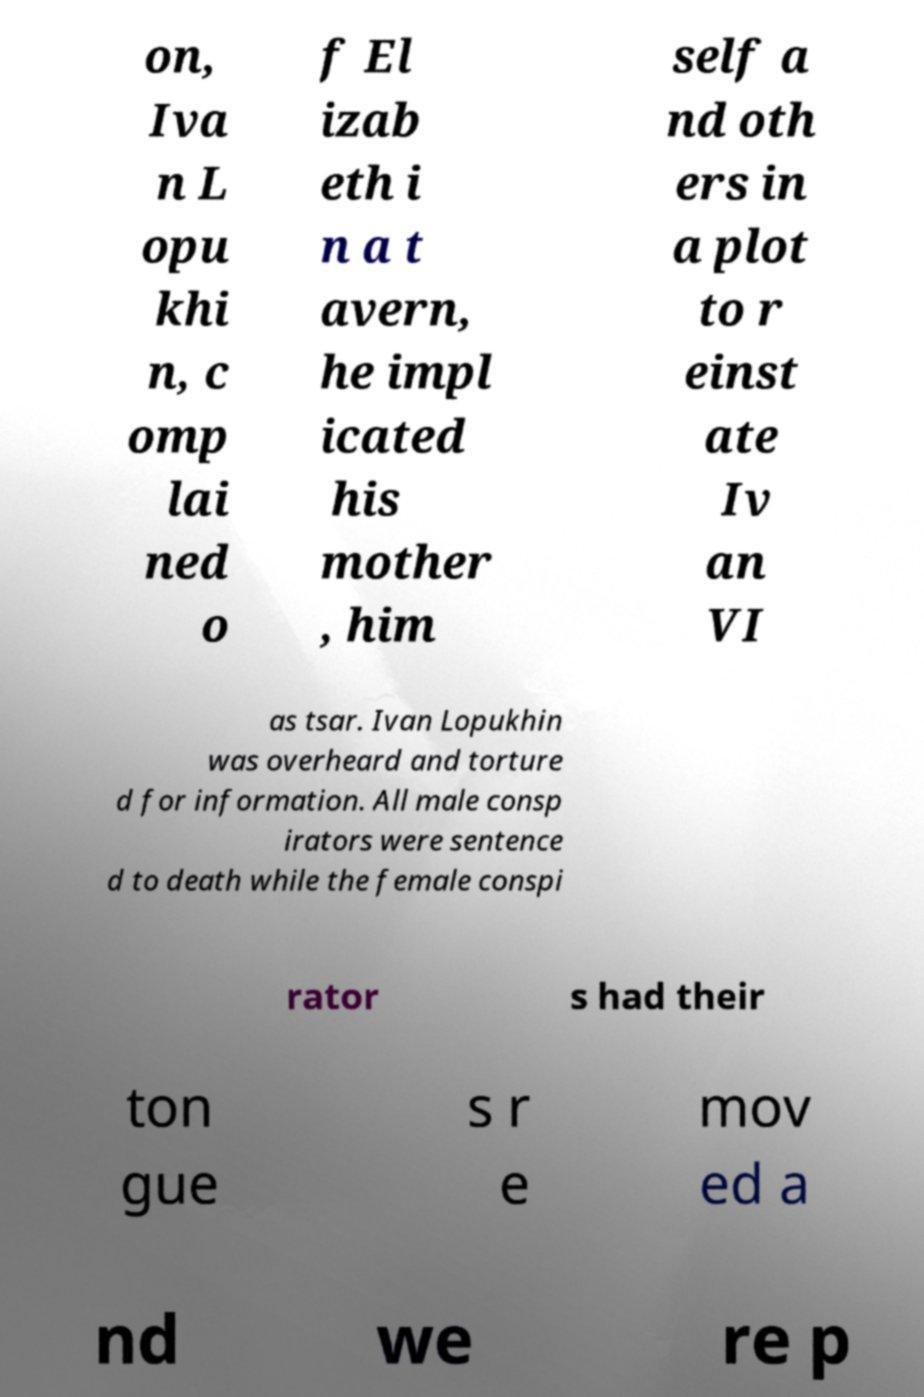What messages or text are displayed in this image? I need them in a readable, typed format. on, Iva n L opu khi n, c omp lai ned o f El izab eth i n a t avern, he impl icated his mother , him self a nd oth ers in a plot to r einst ate Iv an VI as tsar. Ivan Lopukhin was overheard and torture d for information. All male consp irators were sentence d to death while the female conspi rator s had their ton gue s r e mov ed a nd we re p 